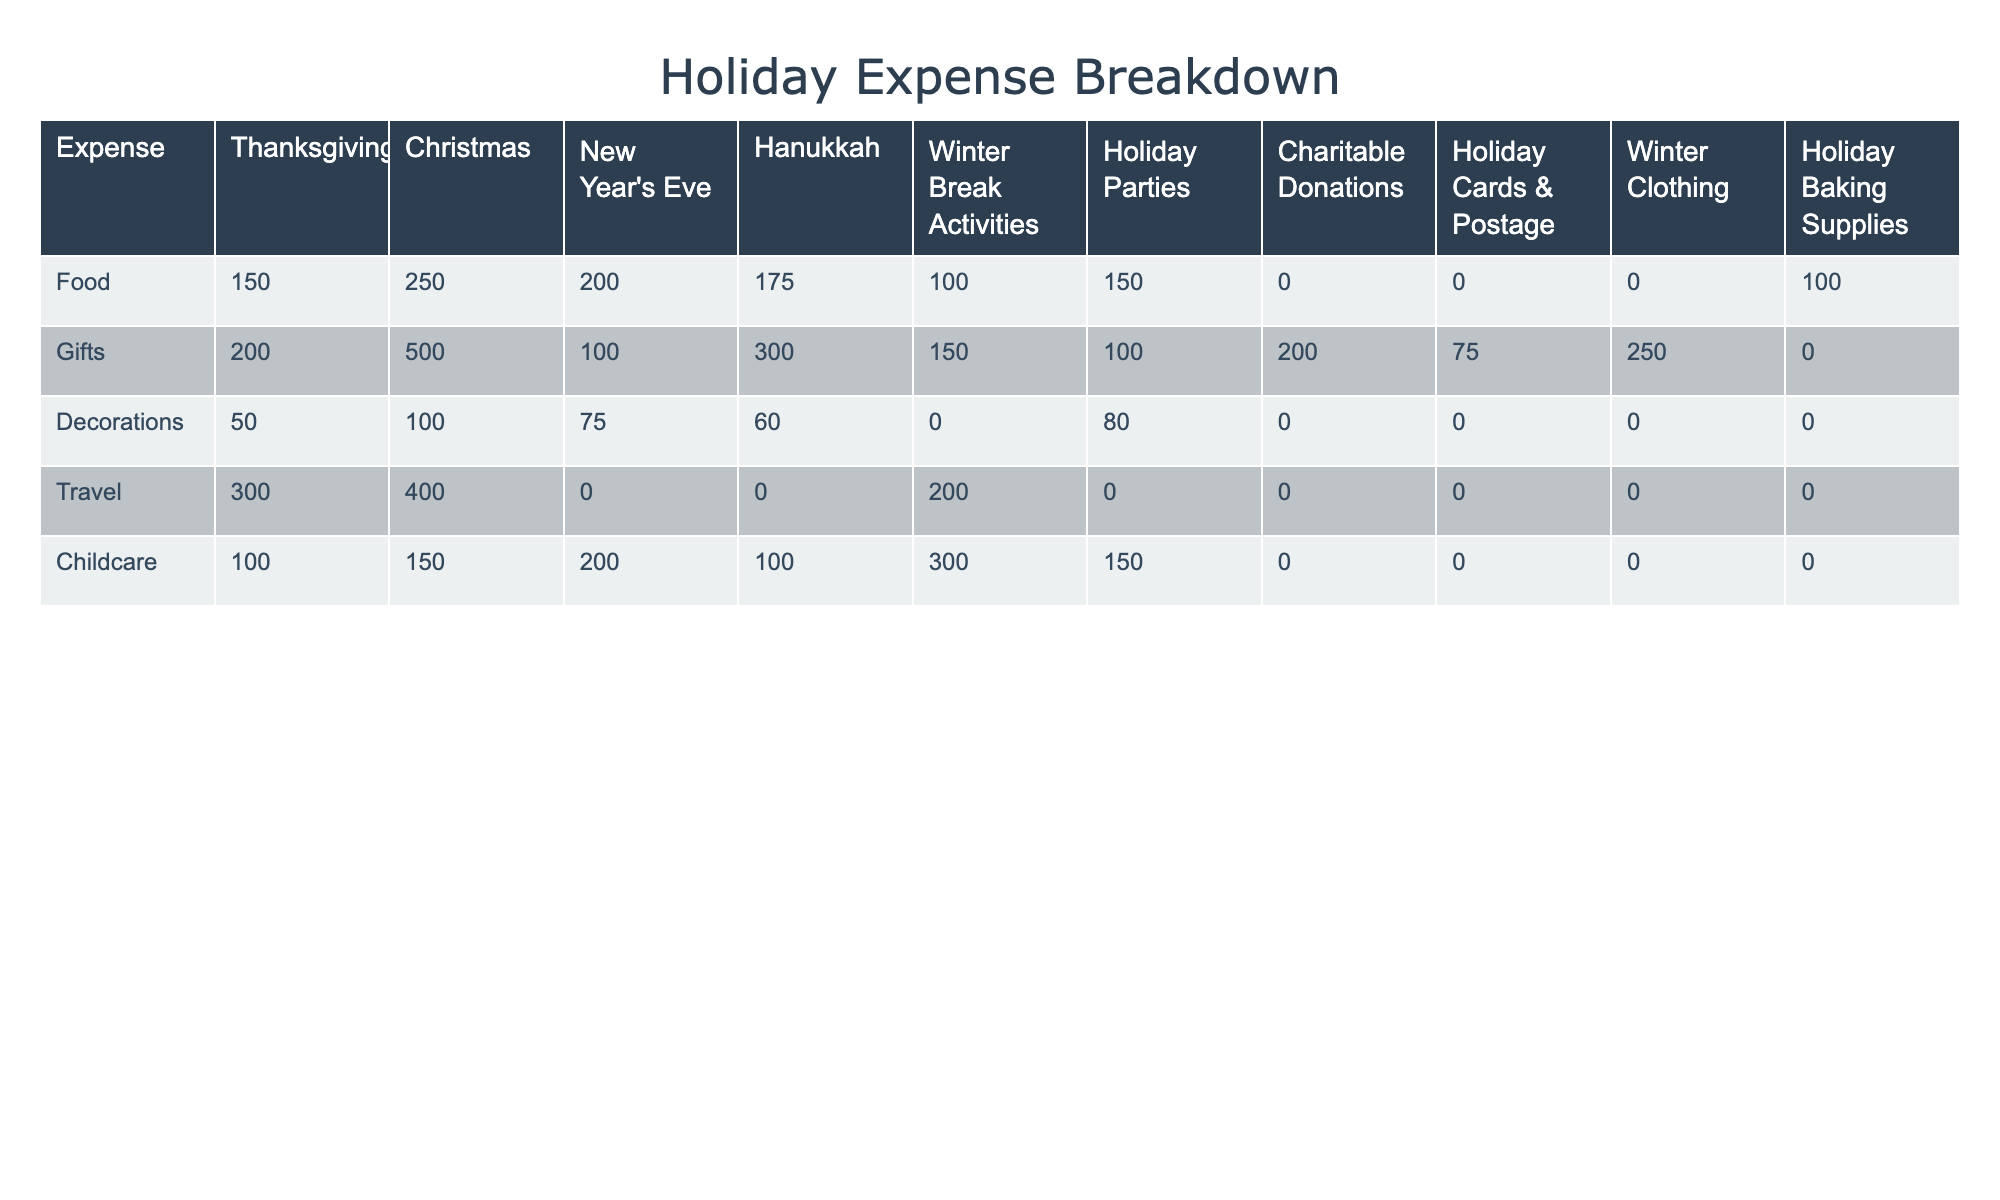What's the total budget for Christmas expenses? By adding the values in the Christmas row (250 for Food, 500 for Gifts, 100 for Decorations, 400 for Travel, and 150 for Childcare), the total expenses for Christmas are calculated as: 250 + 500 + 100 + 400 + 150 = 1400.
Answer: 1400 Which category has the highest total spending across all holidays? To find the highest category, we need to sum each column: Food (150+250+200+175+100+150+0+0+0+100 = 1025), Gifts (200+500+100+300+150+100+200+75+250+0 = 1975), Decorations (50+100+75+60+0+80+0+0+0+0 = 365), Travel (300+400+0+0+200+0+0+0+0+0 = 900), Childcare (100+150+200+100+300+150+0+0+0+0 = 1100). The Gifts category has the highest total of 1975.
Answer: Gifts How much is spent on Hanukkah compared to New Year's Eve? For Hanukkah, total spending is calculated as: 175 (Food) + 300 (Gifts) + 60 (Decorations) + 0 (Travel) + 100 (Childcare) = 635. For New Year's Eve, total spending is: 200 (Food) + 100 (Gifts) + 75 (Decorations) + 0 (Travel) + 200 (Childcare) = 575. So Hanukkah expenses (635) are greater than New Year's Eve expenses (575) by 635 - 575 = 60.
Answer: Hanukkah is higher by 60 What percentage of the Christmas budget is allocated to gifts? The total budget for Christmas is 1400 (as calculated previously) and the amount allocated to gifts is 500. To find the percentage, we calculate (500 / 1400) * 100 = 35.71%.
Answer: 35.71% Total spending on Winter Clothing is 250. Is this higher or lower than the total spent on holiday cards and postage? The total spending on Winter Clothing is 250 and for Holiday Cards & Postage, the expense is 75. Since 250 is greater than 75, it is determined that Winter Clothing expenses are higher.
Answer: Higher If we only consider food expenses, which holiday has the lowest spending? The food expenses for each holiday are as follows: Thanksgiving $150, Christmas $250, New Year's Eve $200, Hanukkah $175, Winter Break Activities $100, and Holiday Parties $150. The lowest expenditure is Winter Break Activities at $100.
Answer: Winter Break Activities What is the variance in spending on childcare during the holidays? Childcare expenses for each holiday are 100, 150, 200, 100, 300, 150, and 0. First, we calculate the mean: (100 + 150 + 200 + 100 + 300 + 150 + 0) / 7 = 125. Then we find the squared differences from the mean: (100-125)² = 625, (150-125)² = 625, (200-125)² = 5625, (100-125)² = 625, (300-125)² = 30625, (150-125)² = 625, (0-125)² = 15625. The variance is the average of these squared differences: (625 + 625 + 5625 + 625 + 30625 + 625 + 15625) / 7 = 6075.
Answer: 6075 What's the total amount dedicated to charitable donations across all holidays? The table shows that the amount for Charitable Donations is only listed under that category, which is 200. Therefore, the total amount dedicated to charitable donations is simply 200.
Answer: 200 